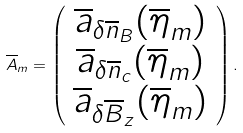<formula> <loc_0><loc_0><loc_500><loc_500>\overline { A } _ { m } = \left ( \begin{array} { c } \overline { a } _ { \delta \overline { n } _ { B } } ( \overline { \eta } _ { m } ) \\ \overline { a } _ { \delta \overline { n } _ { c } } ( \overline { \eta } _ { m } ) \\ \overline { a } _ { \delta \overline { B } _ { z } } ( \overline { \eta } _ { m } ) \\ \end{array} \right ) .</formula> 